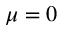Convert formula to latex. <formula><loc_0><loc_0><loc_500><loc_500>\mu = 0</formula> 